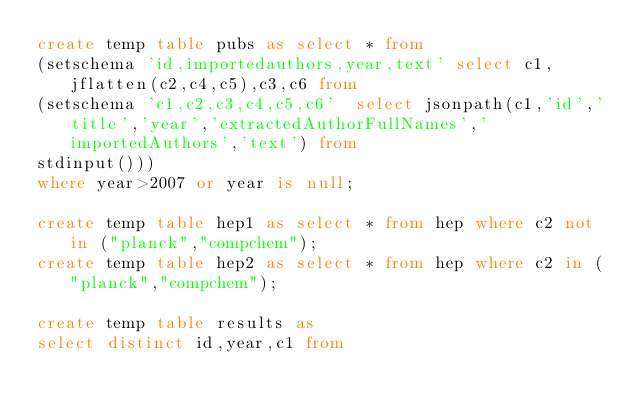Convert code to text. <code><loc_0><loc_0><loc_500><loc_500><_SQL_>create temp table pubs as select * from 
(setschema 'id,importedauthors,year,text' select c1,jflatten(c2,c4,c5),c3,c6 from 
(setschema 'c1,c2,c3,c4,c5,c6'  select jsonpath(c1,'id','title','year','extractedAuthorFullNames','importedAuthors','text') from 
stdinput())) 
where year>2007 or year is null;

create temp table hep1 as select * from hep where c2 not in ("planck","compchem");
create temp table hep2 as select * from hep where c2 in ("planck","compchem");

create temp table results as 
select distinct id,year,c1 from  </code> 